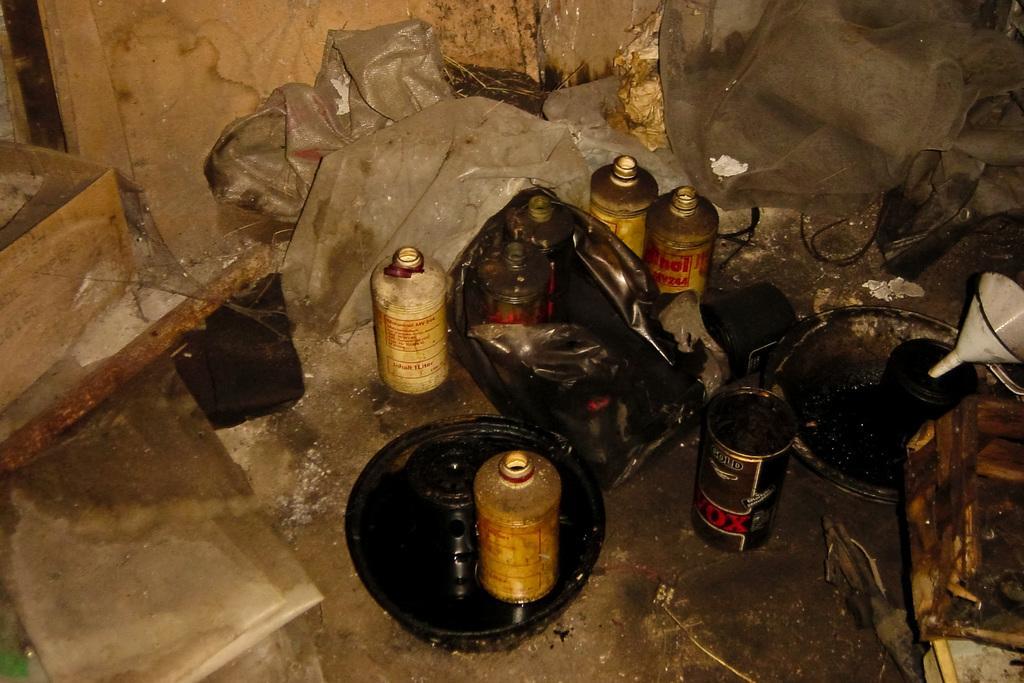Describe this image in one or two sentences. There are seven bottles,bowls and funnel ,wooden box on the floor. We can see in the background wall and covers. 